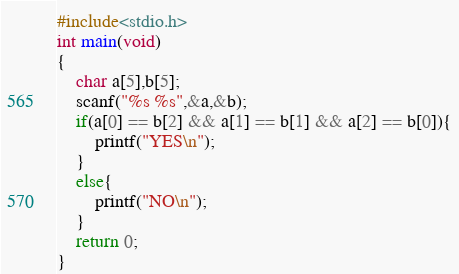Convert code to text. <code><loc_0><loc_0><loc_500><loc_500><_C_>#include<stdio.h>
int main(void)
{
	char a[5],b[5];
	scanf("%s %s",&a,&b);
	if(a[0] == b[2] && a[1] == b[1] && a[2] == b[0]){
		printf("YES\n");
	}
	else{
		printf("NO\n");
	}
	return 0;
}</code> 